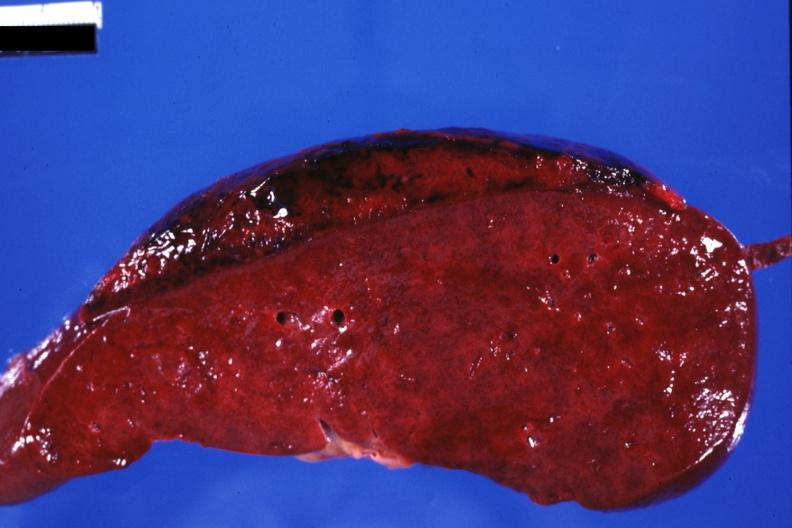what is present?
Answer the question using a single word or phrase. Hematologic 